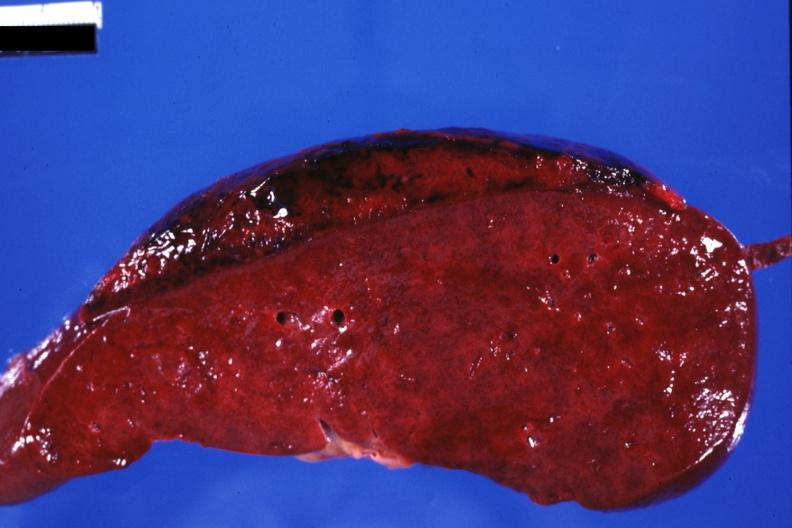what is present?
Answer the question using a single word or phrase. Hematologic 